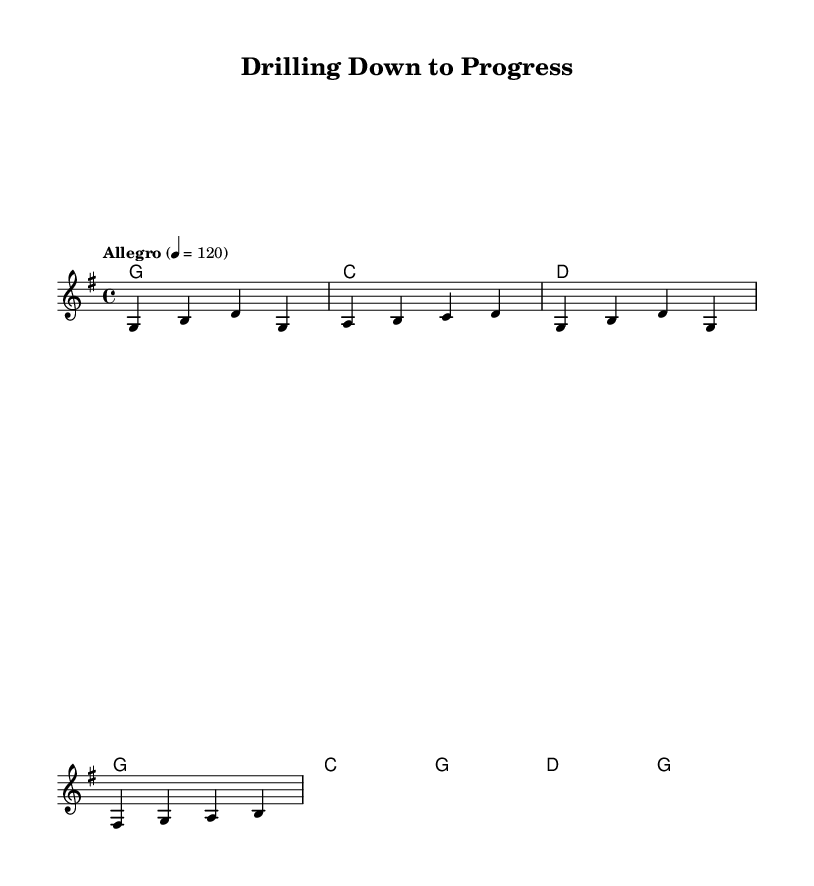What is the key signature of this music? The key signature is denoted by the presence of one sharp in the key of G major. In G major, there is one sharp (F#), which is indicated at the beginning of the staff.
Answer: G major What is the time signature of this music? The time signature is presented at the beginning of the score and is indicated as 4/4, meaning there are four beats in each measure, and the quarter note gets one beat.
Answer: 4/4 What tempo marking is used in this music? The tempo marking is specified above the staff and states "Allegro" with a metronome mark of 120. "Allegro" indicates a fast pace, and the number signifies the beats per minute (BPM).
Answer: Allegro, 120 How many measures are in the melody section? By counting the distinct groups of notes with their respective bar lines, we can see that there are four measures in the melody section.
Answer: 4 What is the primary theme of the lyrics? Analyzing the lyrics presented, the theme revolves around technological advancements in drilling and extraction, emphasizing innovation and cleaner energy.
Answer: Technological advancements What type of chord progression is indicated in the harmony section? The chord progression follows a common country rock pattern, with a use of G major, C major, and D major, creating a familiar and upbeat sound typical in country rock music.
Answer: G, C, D What are the main subjects discussed in the chorus? The chorus addresses the concepts of innovation and clean energy as goals within the drilling and extraction industry, making it relevant to the theme of the song.
Answer: Innovation, clean energy 